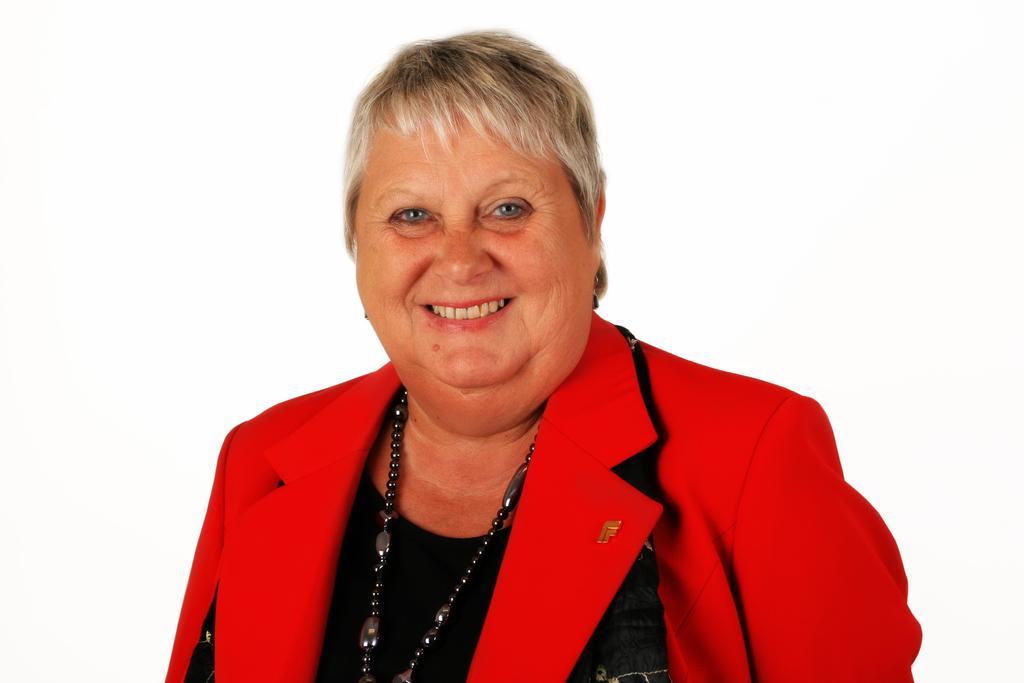Could you give a brief overview of what you see in this image? In this image I can see a woman smiling. She is wearing red and black color dress and black chain. Background is white in color. 